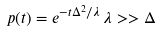Convert formula to latex. <formula><loc_0><loc_0><loc_500><loc_500>p ( t ) = e ^ { - t \Delta ^ { 2 } / \lambda } \, \lambda > > \Delta</formula> 